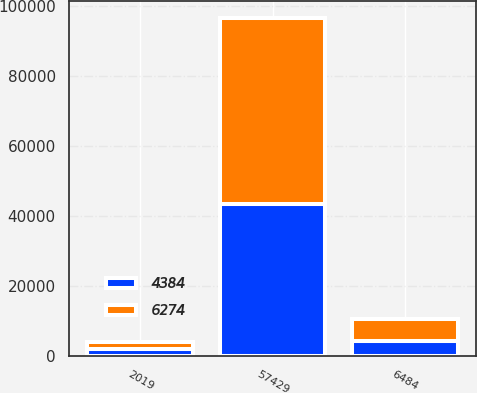Convert chart. <chart><loc_0><loc_0><loc_500><loc_500><stacked_bar_chart><ecel><fcel>2019<fcel>57429<fcel>6484<nl><fcel>6274<fcel>2018<fcel>53161<fcel>6274<nl><fcel>4384<fcel>2017<fcel>43571<fcel>4384<nl></chart> 